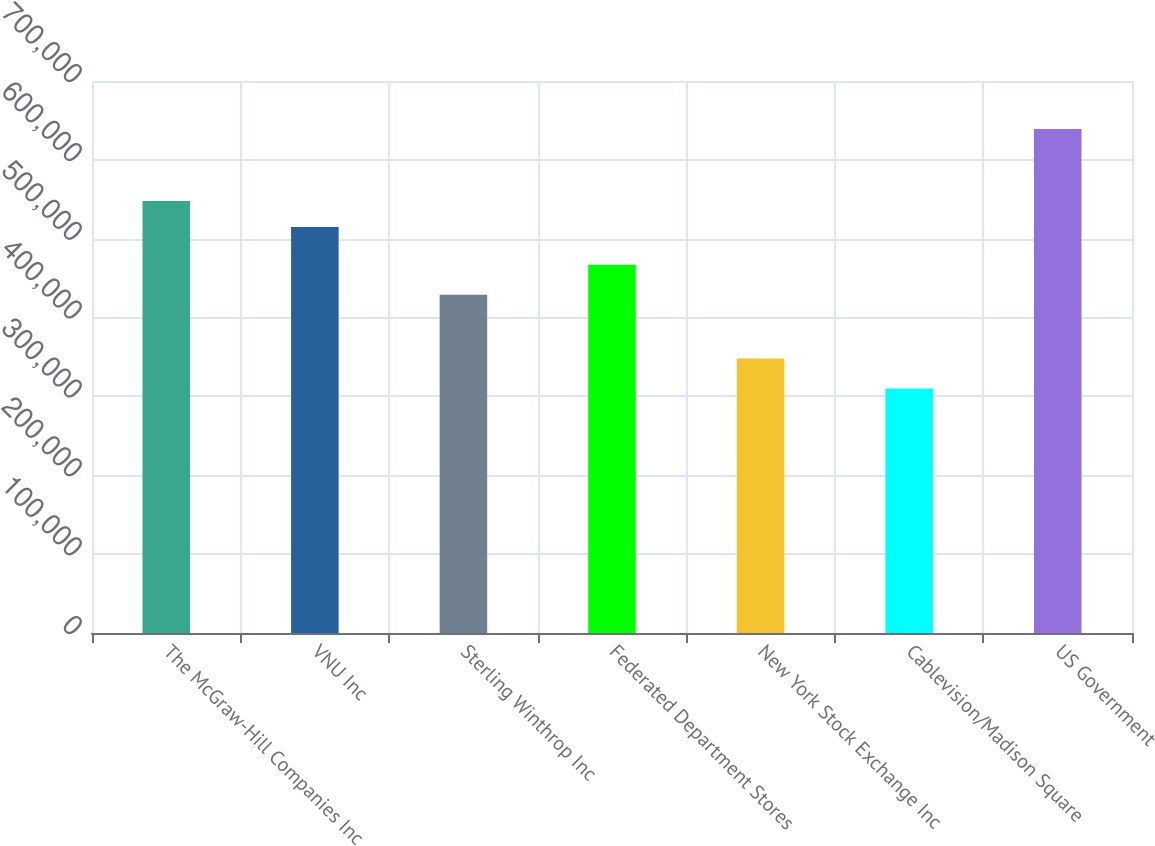Convert chart. <chart><loc_0><loc_0><loc_500><loc_500><bar_chart><fcel>The McGraw-Hill Companies Inc<fcel>VNU Inc<fcel>Sterling Winthrop Inc<fcel>Federated Department Stores<fcel>New York Stock Exchange Inc<fcel>Cablevision/Madison Square<fcel>US Government<nl><fcel>547900<fcel>515000<fcel>429000<fcel>467000<fcel>348000<fcel>310000<fcel>639000<nl></chart> 